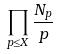<formula> <loc_0><loc_0><loc_500><loc_500>\prod _ { p \leq X } \frac { N _ { p } } { p }</formula> 